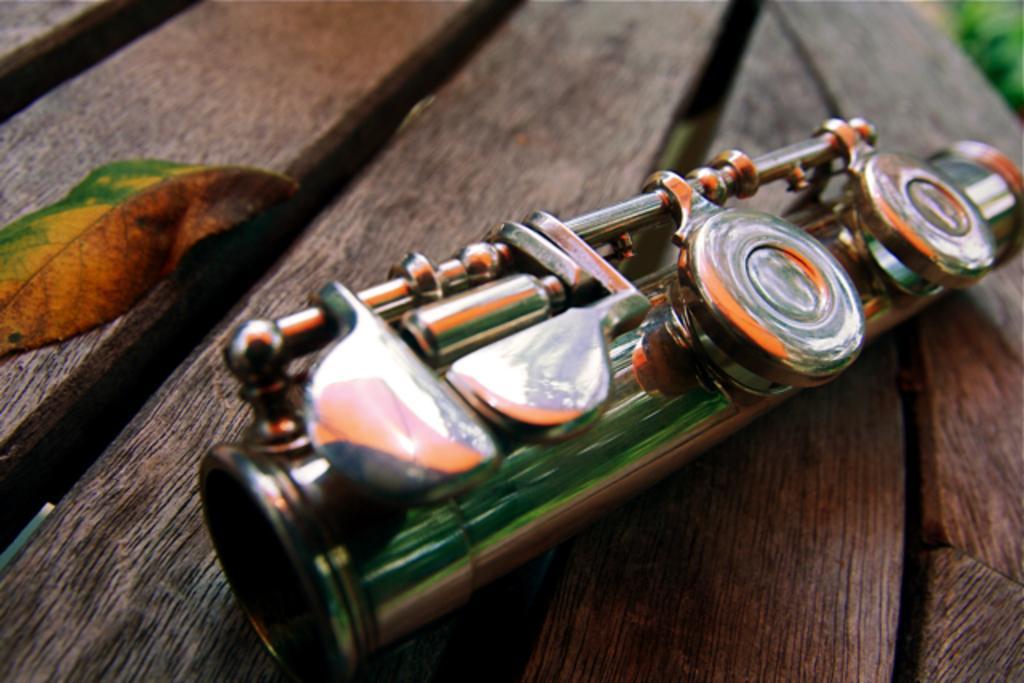How would you summarize this image in a sentence or two? This image consists of a musical instrument in the middle. There is a leaf on the left side. They are placed on a table. 